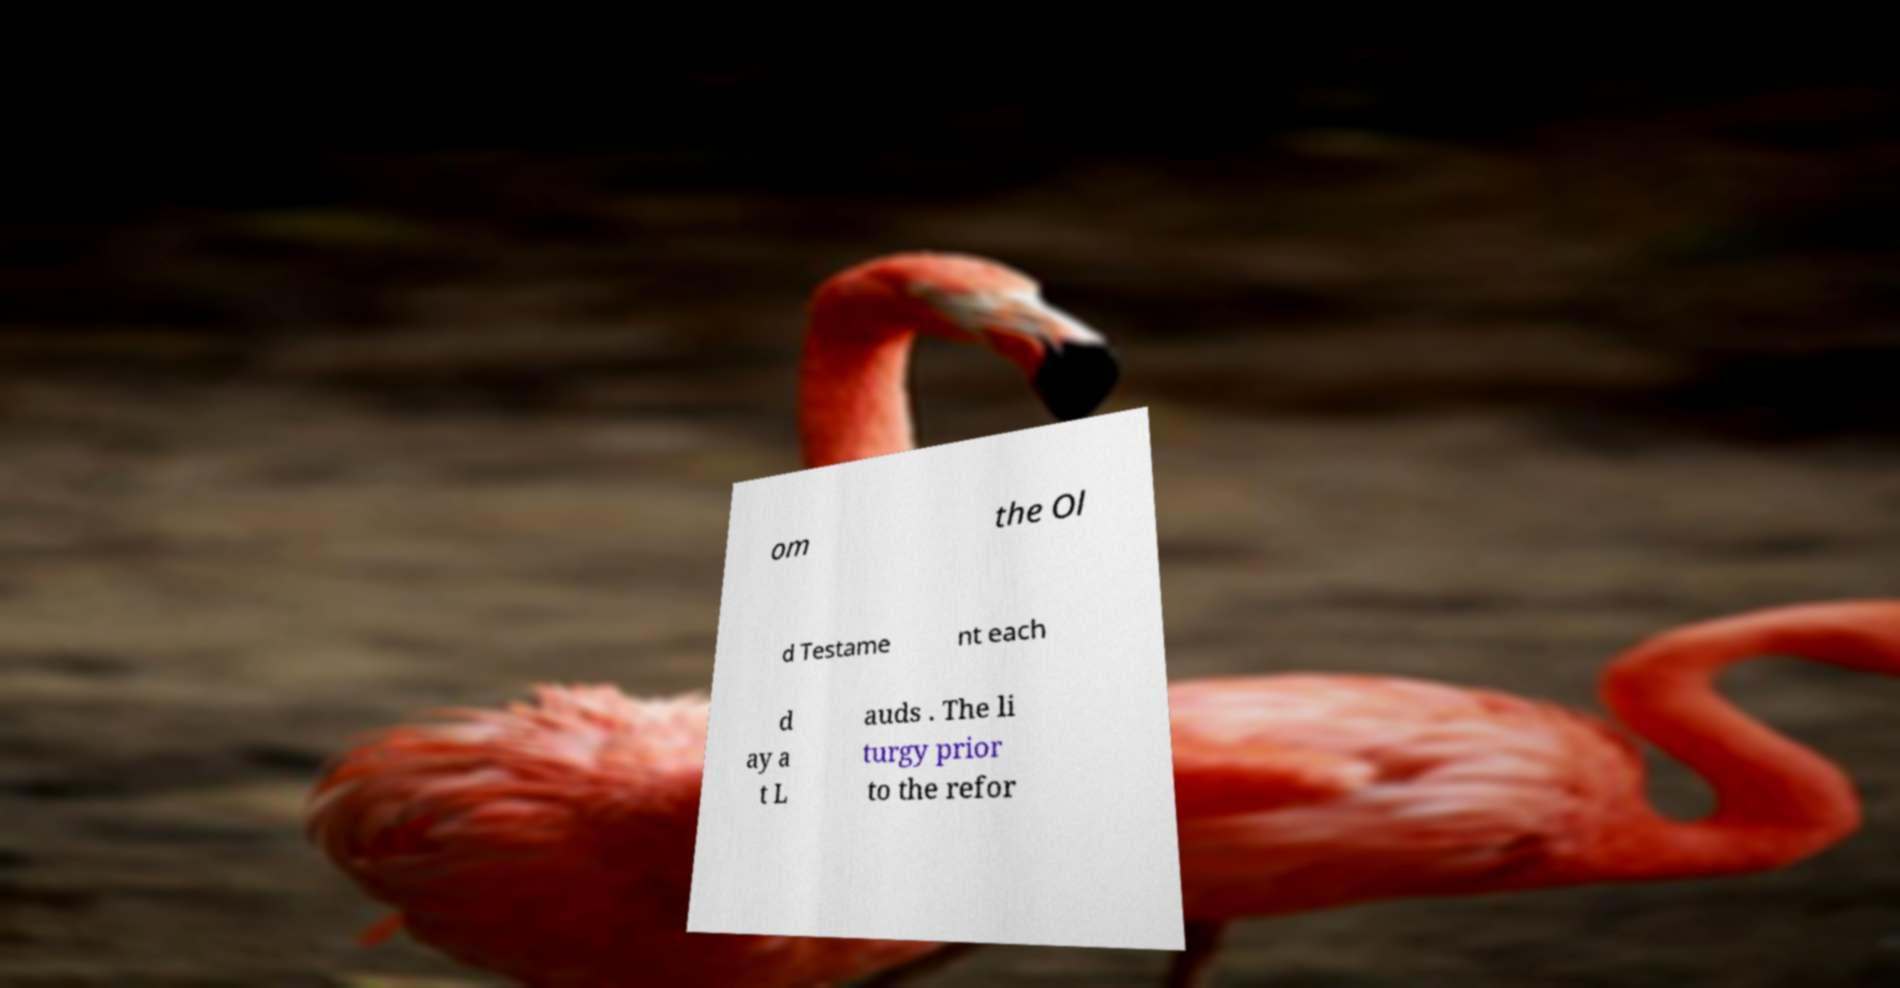Could you assist in decoding the text presented in this image and type it out clearly? om the Ol d Testame nt each d ay a t L auds . The li turgy prior to the refor 